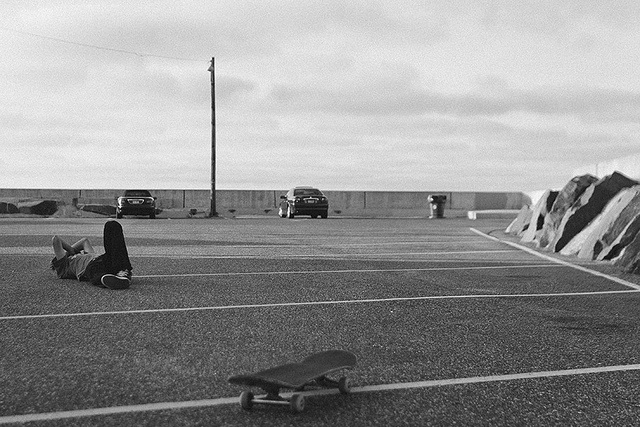Describe the objects in this image and their specific colors. I can see skateboard in gray, black, and lightgray tones, people in lightgray, black, gray, and darkgray tones, car in lightgray, black, gray, and darkgray tones, and car in lightgray, black, gray, and darkgray tones in this image. 